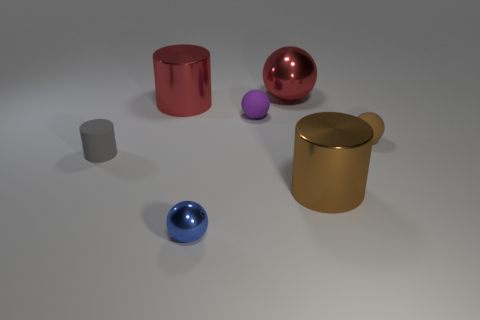Is there a small metal thing that is behind the small ball in front of the gray thing?
Make the answer very short. No. What number of large red metal spheres are behind the rubber object to the left of the large thing that is on the left side of the red sphere?
Provide a short and direct response. 1. Is the number of big balls less than the number of brown metal blocks?
Ensure brevity in your answer.  No. There is a tiny thing that is in front of the big brown metallic cylinder; does it have the same shape as the big thing that is in front of the tiny brown ball?
Your response must be concise. No. What color is the rubber cylinder?
Make the answer very short. Gray. How many rubber things are either small purple things or big things?
Your answer should be compact. 1. There is a small metallic object that is the same shape as the small brown matte object; what is its color?
Give a very brief answer. Blue. Is there a tiny green cylinder?
Your answer should be very brief. No. Do the brown thing that is in front of the small cylinder and the sphere that is behind the large red metal cylinder have the same material?
Ensure brevity in your answer.  Yes. What is the shape of the metal thing that is the same color as the large metallic sphere?
Your response must be concise. Cylinder. 